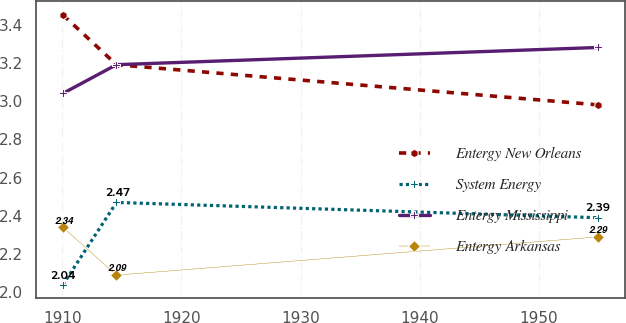<chart> <loc_0><loc_0><loc_500><loc_500><line_chart><ecel><fcel>Entergy New Orleans<fcel>System Energy<fcel>Entergy Mississippi<fcel>Entergy Arkansas<nl><fcel>1910.05<fcel>3.45<fcel>2.04<fcel>3.04<fcel>2.34<nl><fcel>1914.54<fcel>3.19<fcel>2.47<fcel>3.19<fcel>2.09<nl><fcel>1954.98<fcel>2.98<fcel>2.39<fcel>3.28<fcel>2.29<nl></chart> 